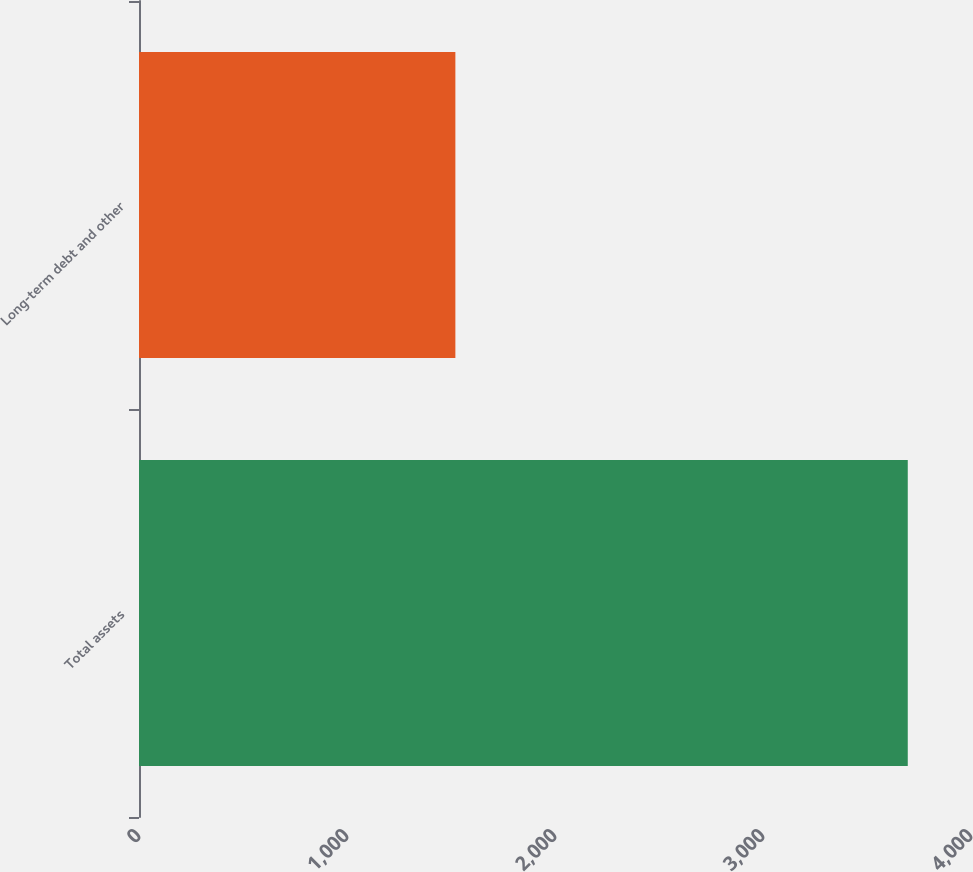Convert chart to OTSL. <chart><loc_0><loc_0><loc_500><loc_500><bar_chart><fcel>Total assets<fcel>Long-term debt and other<nl><fcel>3696<fcel>1521<nl></chart> 